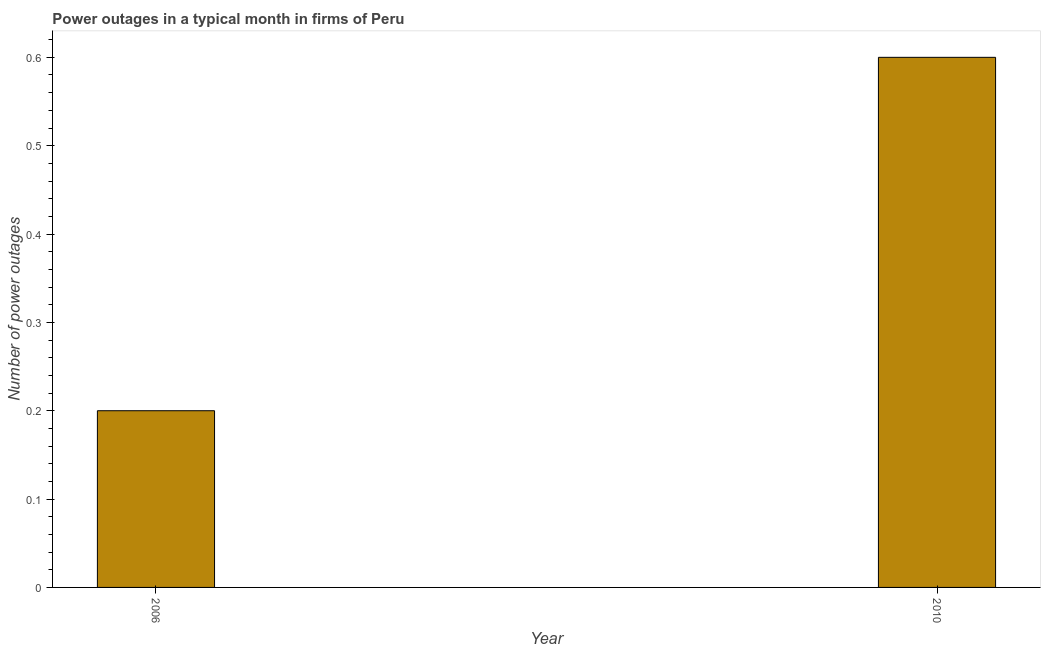What is the title of the graph?
Your answer should be very brief. Power outages in a typical month in firms of Peru. What is the label or title of the X-axis?
Ensure brevity in your answer.  Year. What is the label or title of the Y-axis?
Keep it short and to the point. Number of power outages. What is the number of power outages in 2010?
Your answer should be compact. 0.6. In which year was the number of power outages minimum?
Your response must be concise. 2006. What is the sum of the number of power outages?
Your response must be concise. 0.8. In how many years, is the number of power outages greater than 0.3 ?
Your response must be concise. 1. What is the ratio of the number of power outages in 2006 to that in 2010?
Your response must be concise. 0.33. How many bars are there?
Provide a short and direct response. 2. Are all the bars in the graph horizontal?
Your response must be concise. No. How many years are there in the graph?
Provide a short and direct response. 2. What is the difference between two consecutive major ticks on the Y-axis?
Provide a short and direct response. 0.1. What is the Number of power outages of 2006?
Provide a succinct answer. 0.2. What is the ratio of the Number of power outages in 2006 to that in 2010?
Offer a very short reply. 0.33. 